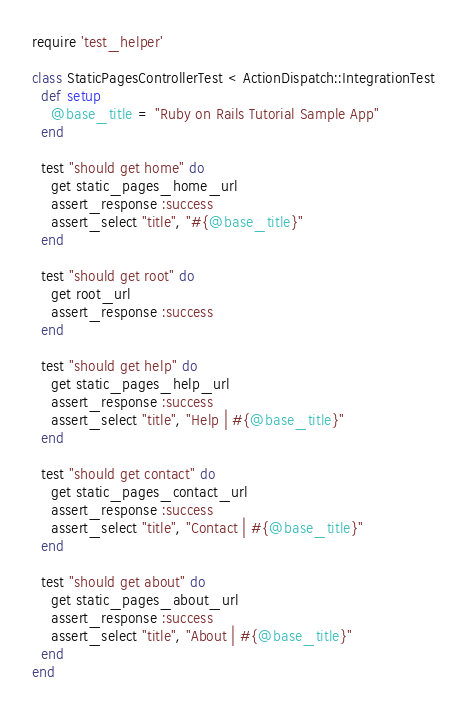<code> <loc_0><loc_0><loc_500><loc_500><_Ruby_>require 'test_helper'

class StaticPagesControllerTest < ActionDispatch::IntegrationTest
  def setup
    @base_title = "Ruby on Rails Tutorial Sample App"
  end

  test "should get home" do
    get static_pages_home_url
    assert_response :success
    assert_select "title", "#{@base_title}"
  end

  test "should get root" do
    get root_url
    assert_response :success
  end

  test "should get help" do
    get static_pages_help_url
    assert_response :success
    assert_select "title", "Help | #{@base_title}"
  end

  test "should get contact" do
    get static_pages_contact_url
    assert_response :success
    assert_select "title", "Contact | #{@base_title}"
  end

  test "should get about" do
    get static_pages_about_url
    assert_response :success
    assert_select "title", "About | #{@base_title}"
  end
end
</code> 